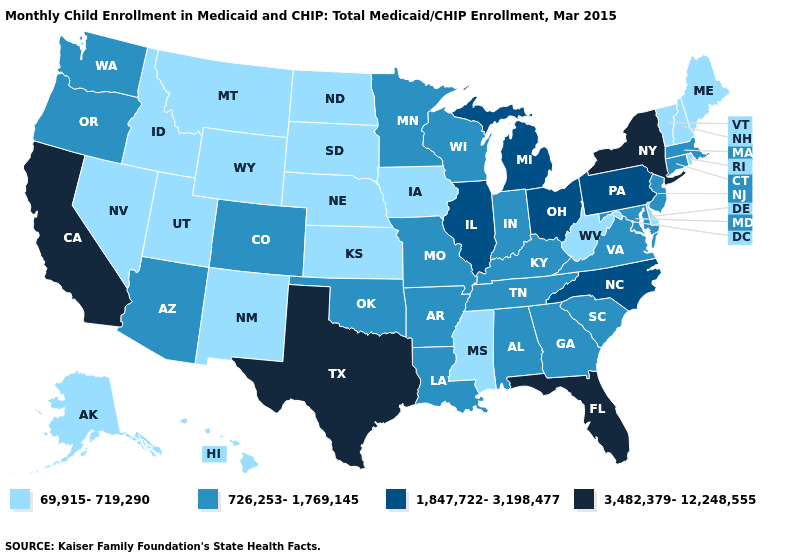Does Rhode Island have the lowest value in the USA?
Write a very short answer. Yes. What is the highest value in the USA?
Give a very brief answer. 3,482,379-12,248,555. Name the states that have a value in the range 69,915-719,290?
Write a very short answer. Alaska, Delaware, Hawaii, Idaho, Iowa, Kansas, Maine, Mississippi, Montana, Nebraska, Nevada, New Hampshire, New Mexico, North Dakota, Rhode Island, South Dakota, Utah, Vermont, West Virginia, Wyoming. Which states have the highest value in the USA?
Write a very short answer. California, Florida, New York, Texas. Among the states that border Kansas , does Nebraska have the highest value?
Write a very short answer. No. Which states hav the highest value in the Northeast?
Short answer required. New York. Among the states that border Kansas , which have the highest value?
Be succinct. Colorado, Missouri, Oklahoma. What is the value of Wyoming?
Short answer required. 69,915-719,290. What is the lowest value in the West?
Answer briefly. 69,915-719,290. What is the highest value in the West ?
Be succinct. 3,482,379-12,248,555. What is the value of Indiana?
Write a very short answer. 726,253-1,769,145. What is the value of Missouri?
Keep it brief. 726,253-1,769,145. Name the states that have a value in the range 3,482,379-12,248,555?
Quick response, please. California, Florida, New York, Texas. Which states have the lowest value in the MidWest?
Short answer required. Iowa, Kansas, Nebraska, North Dakota, South Dakota. Does the map have missing data?
Short answer required. No. 